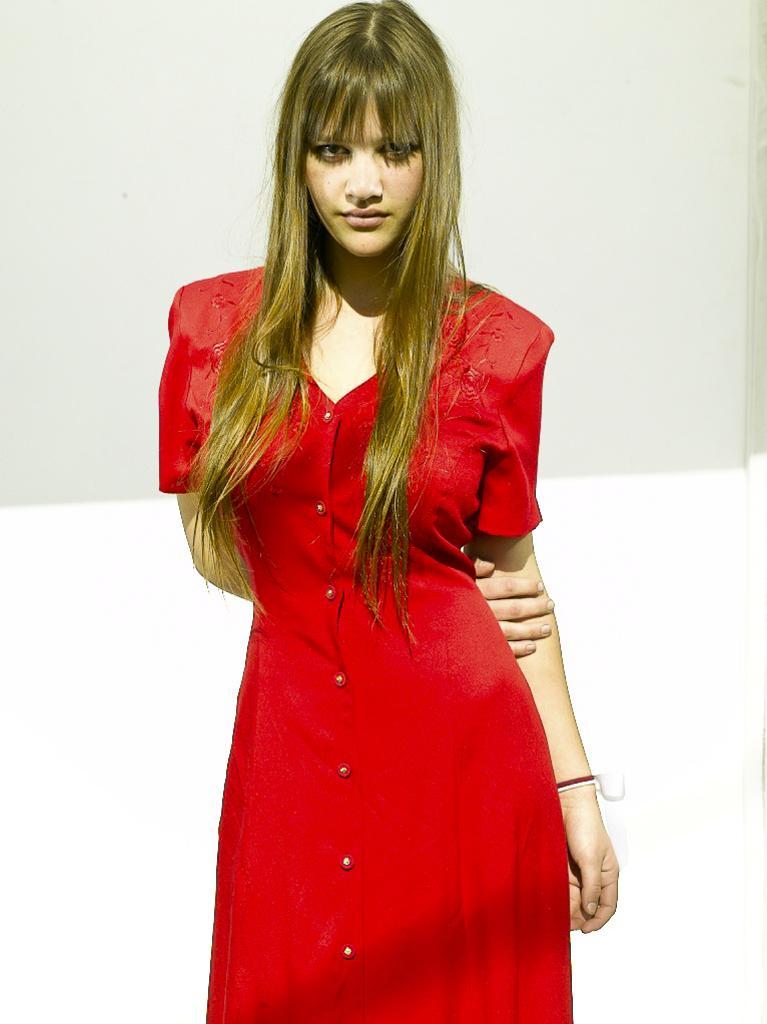Can you describe this image briefly? In the image we can see a woman standing and wearing red color dress. This is a hand band and the background is white and pale gray in color. 